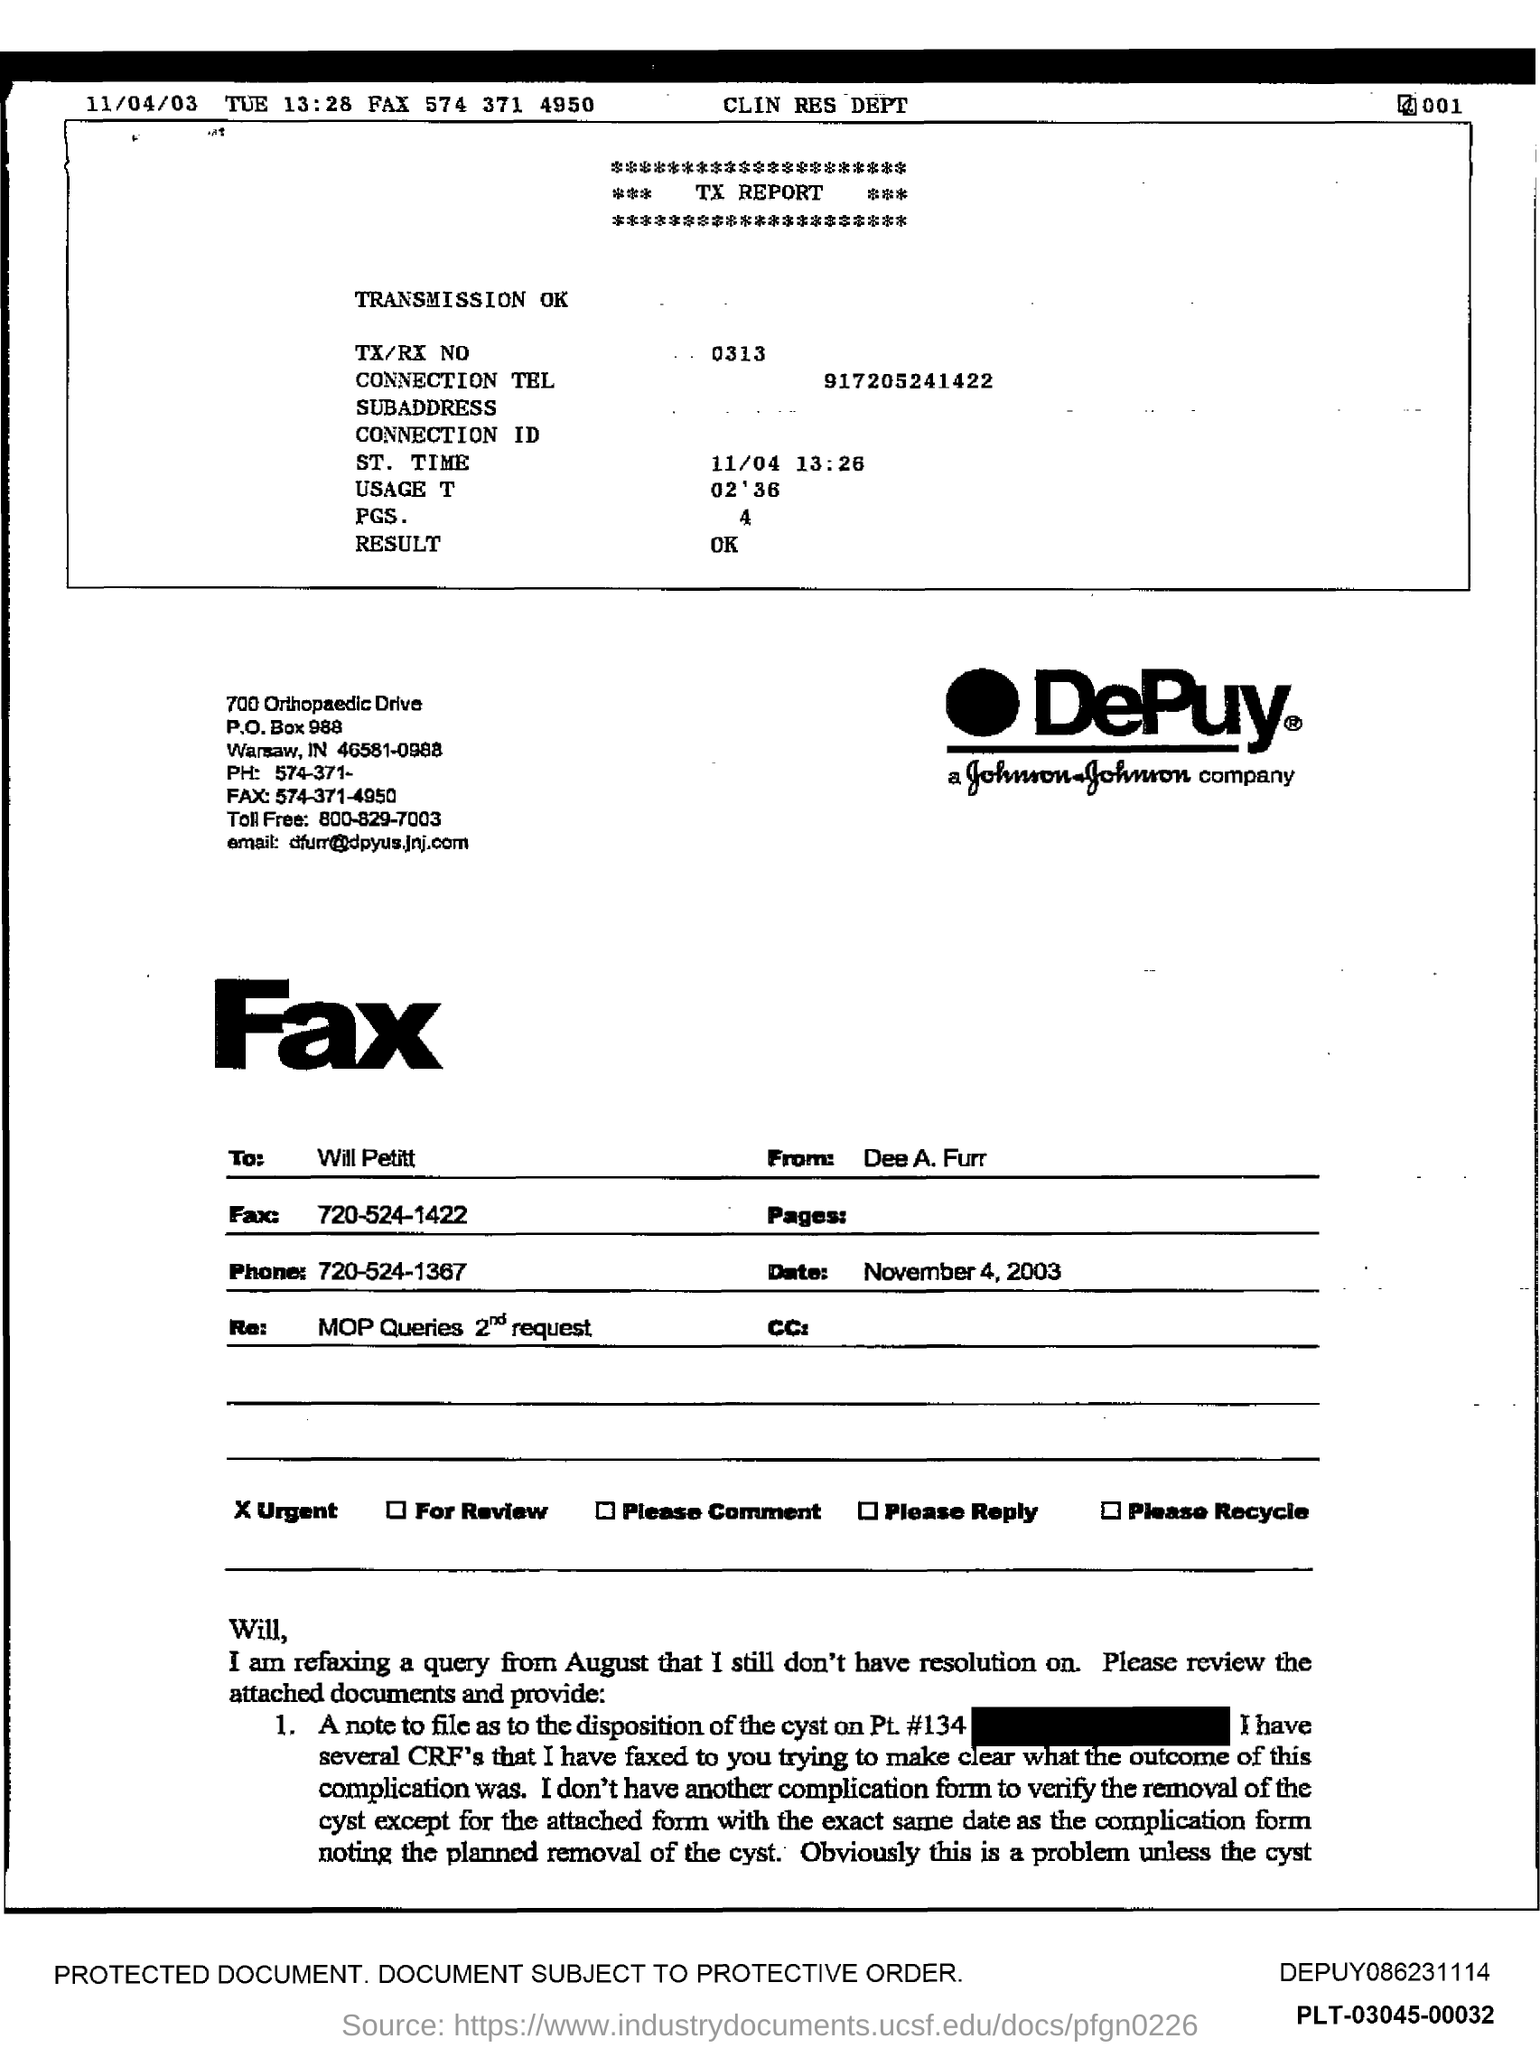Is there an urgency indicated for the content of this fax? Yes, there's a checkbox marked 'Urgent' at the bottom of the fax, suggesting that the sender considers the information within to be of immediate importance. Could you summarize the content of the fax for me? The fax is addressed to Will Pettit and discusses an unresolved query from August regarding the disposition of a cyst on patient number 134. The sender, Dee A. Furr, requests a review of attached documents to clarify the outcome. 